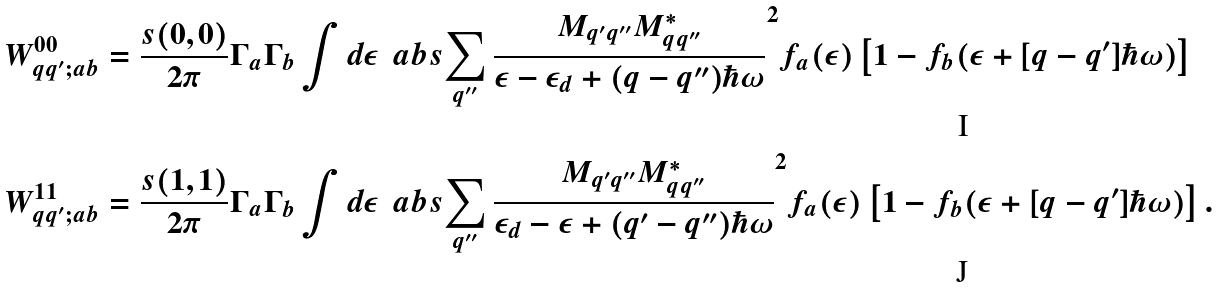Convert formula to latex. <formula><loc_0><loc_0><loc_500><loc_500>W ^ { 0 0 } _ { q q ^ { \prime } ; a b } & = \frac { s ( 0 , 0 ) } { 2 \pi } \Gamma _ { a } \Gamma _ { b } \int d \epsilon \, \ a b s { \sum _ { q ^ { \prime \prime } } \frac { M _ { q ^ { \prime } q ^ { \prime \prime } } M _ { q q ^ { \prime \prime } } ^ { * } } { \epsilon - \epsilon _ { d } + ( q - q ^ { \prime \prime } ) \hbar { \omega } } } ^ { 2 } f _ { a } ( \epsilon ) \left [ 1 - f _ { b } ( \epsilon + [ q - q ^ { \prime } ] \hbar { \omega } ) \right ] \\ W ^ { 1 1 } _ { q q ^ { \prime } ; a b } & = \frac { s ( 1 , 1 ) } { 2 \pi } \Gamma _ { a } \Gamma _ { b } \int d \epsilon \, \ a b s { \sum _ { q ^ { \prime \prime } } \frac { M _ { q ^ { \prime } q ^ { \prime \prime } } M _ { q q ^ { \prime \prime } } ^ { * } } { \epsilon _ { d } - \epsilon + ( q ^ { \prime } - q ^ { \prime \prime } ) \hbar { \omega } } } ^ { 2 } f _ { a } ( \epsilon ) \left [ 1 - f _ { b } ( \epsilon + [ q - q ^ { \prime } ] \hbar { \omega } ) \right ] .</formula> 